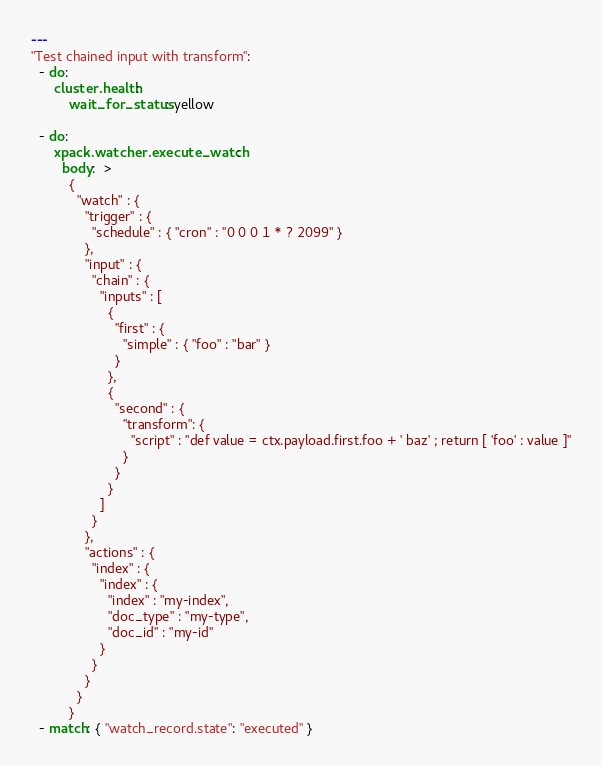Convert code to text. <code><loc_0><loc_0><loc_500><loc_500><_YAML_>---
"Test chained input with transform":
  - do:
      cluster.health:
          wait_for_status: yellow

  - do:
      xpack.watcher.execute_watch:
        body:  >
          {
            "watch" : {
              "trigger" : {
                "schedule" : { "cron" : "0 0 0 1 * ? 2099" }
              },
              "input" : {
                "chain" : {
                  "inputs" : [
                    {
                      "first" : {
                        "simple" : { "foo" : "bar" }
                      }
                    },
                    {
                      "second" : {
                        "transform": {
                          "script" : "def value = ctx.payload.first.foo + ' baz' ; return [ 'foo' : value ]"
                        }
                      }
                    }
                  ]
                }
              },
              "actions" : {
                "index" : {
                  "index" : {
                    "index" : "my-index",
                    "doc_type" : "my-type",
                    "doc_id" : "my-id"
                  }
                }
              }
            }
          }
  - match: { "watch_record.state": "executed" }</code> 